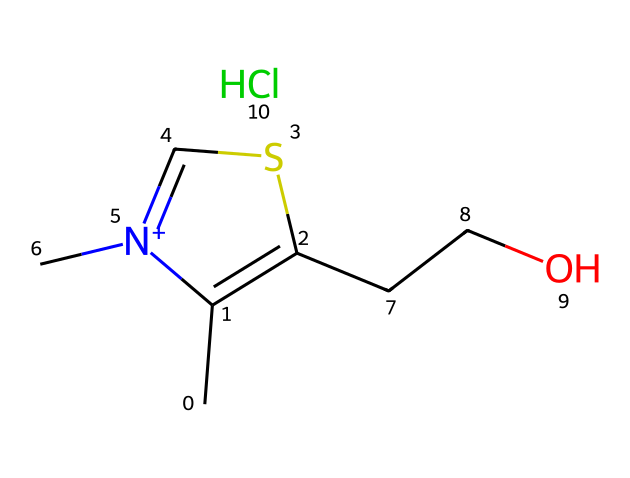What is the molecular formula of thiamine? The SMILES representation can be analyzed to identify the molecular formula. Counting all the carbon (C), hydrogen (H), nitrogen (N), oxygen (O), and sulfur (S) atoms gives: C12, H17, N4, O2, S.
Answer: C12H17N4O2S How many nitrogen atoms are present in thiamine? By examining the SMILES representation, we can clearly identify that there are four nitrogen atoms present in the structure, indicated by the "N" in the formula.
Answer: 4 What element is represented by the 'S' in thiamine? The 'S' stands for sulfur in the chemical structure, which is a key element making this compound a sulfur-containing compound.
Answer: sulfur What type of functional group is present in thiamine? The structure includes a thiazole ring, which is characterized by a sulfur atom bonded to nitrogen and carbon; this is a signature feature of thiazole compounds.
Answer: thiazole ring How many rings are present in thiamine's structure? Observing the chemical structure again, we can see that there is one cyclic structure present, which is the thiazole ring. Rings in organic chemistry are formed by a closed loop of atoms.
Answer: 1 What charge does the nitrogen in thiamine's structure carry? The presence of "N+" in the SMILES notation indicates that one of the nitrogen atoms carries a positive charge.
Answer: positive Which specific type of compound is thiamine classified as? Thiamine is classified as a vitamin, specifically a B-vitamin, due to its essential role in biological functions, including its sulfur-containing structure which categorizes it as a sulfur compound.
Answer: vitamin B1 